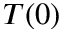<formula> <loc_0><loc_0><loc_500><loc_500>T ( 0 )</formula> 